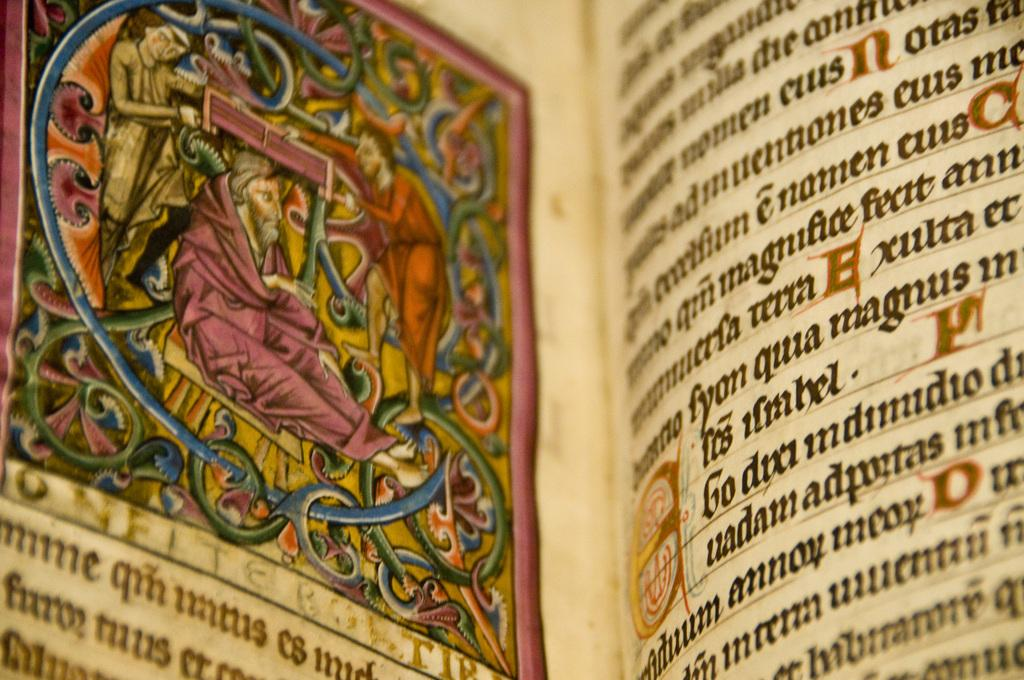<image>
Give a short and clear explanation of the subsequent image. An old text book written in Latin with colorful images inside. 